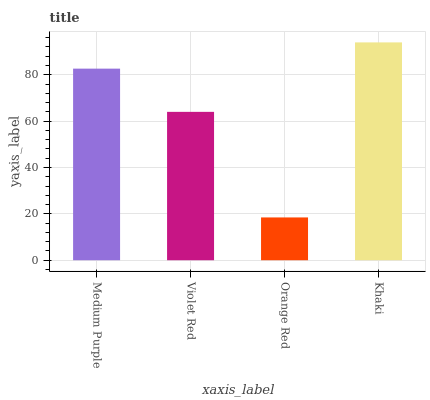Is Orange Red the minimum?
Answer yes or no. Yes. Is Khaki the maximum?
Answer yes or no. Yes. Is Violet Red the minimum?
Answer yes or no. No. Is Violet Red the maximum?
Answer yes or no. No. Is Medium Purple greater than Violet Red?
Answer yes or no. Yes. Is Violet Red less than Medium Purple?
Answer yes or no. Yes. Is Violet Red greater than Medium Purple?
Answer yes or no. No. Is Medium Purple less than Violet Red?
Answer yes or no. No. Is Medium Purple the high median?
Answer yes or no. Yes. Is Violet Red the low median?
Answer yes or no. Yes. Is Khaki the high median?
Answer yes or no. No. Is Orange Red the low median?
Answer yes or no. No. 